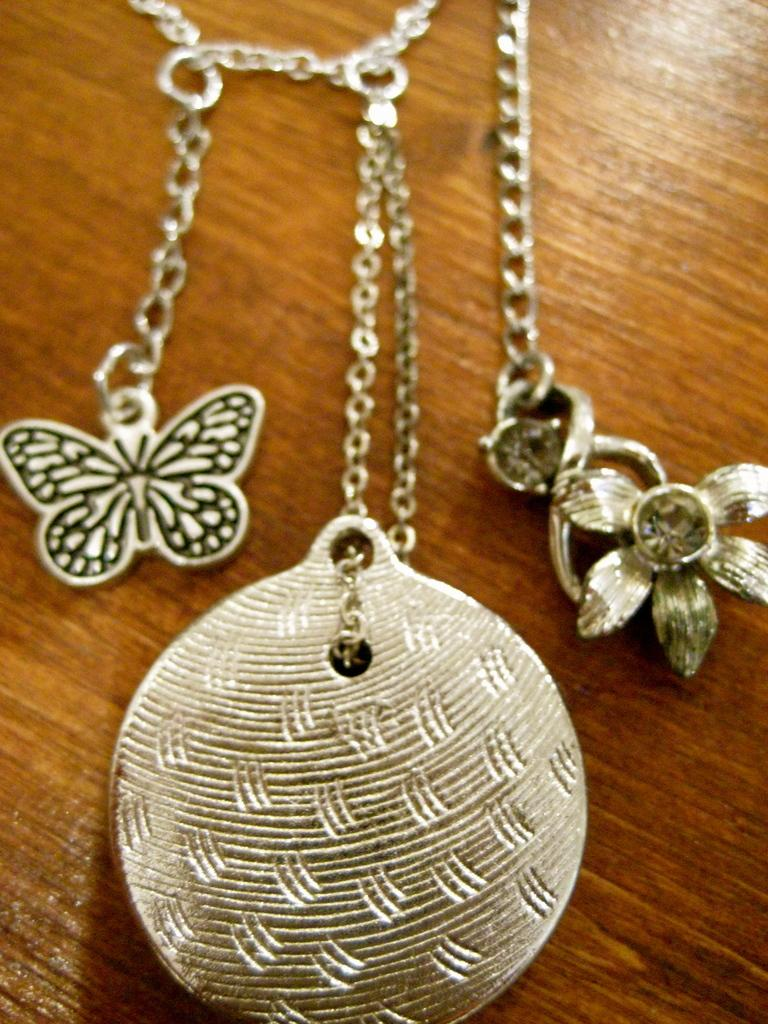What type of jewelry is visible in the image? There are lockets in the image. What is attached to the lockets? There are chains in the image. On what surface are the lockets and chains placed? The lockets and chains are on a wooden surface. Where is the playground located in the image? There is no playground present in the image. What type of stem can be seen growing from the lockets in the image? There are no stems growing from the lockets in the image. 